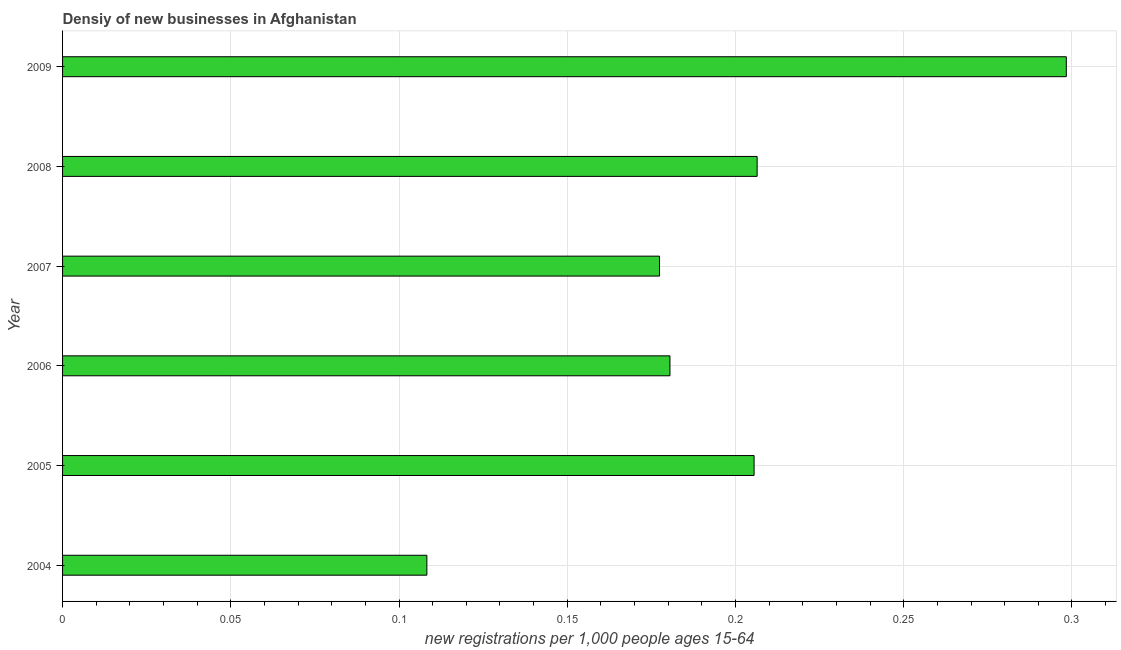What is the title of the graph?
Offer a very short reply. Densiy of new businesses in Afghanistan. What is the label or title of the X-axis?
Make the answer very short. New registrations per 1,0 people ages 15-64. What is the label or title of the Y-axis?
Ensure brevity in your answer.  Year. What is the density of new business in 2007?
Give a very brief answer. 0.18. Across all years, what is the maximum density of new business?
Your answer should be compact. 0.3. Across all years, what is the minimum density of new business?
Keep it short and to the point. 0.11. What is the sum of the density of new business?
Offer a terse response. 1.18. What is the difference between the density of new business in 2004 and 2007?
Keep it short and to the point. -0.07. What is the average density of new business per year?
Ensure brevity in your answer.  0.2. What is the median density of new business?
Your response must be concise. 0.19. What is the ratio of the density of new business in 2005 to that in 2006?
Your answer should be compact. 1.14. What is the difference between the highest and the second highest density of new business?
Offer a terse response. 0.09. Is the sum of the density of new business in 2005 and 2008 greater than the maximum density of new business across all years?
Provide a short and direct response. Yes. What is the difference between the highest and the lowest density of new business?
Provide a short and direct response. 0.19. In how many years, is the density of new business greater than the average density of new business taken over all years?
Keep it short and to the point. 3. How many bars are there?
Give a very brief answer. 6. What is the difference between two consecutive major ticks on the X-axis?
Give a very brief answer. 0.05. What is the new registrations per 1,000 people ages 15-64 of 2004?
Give a very brief answer. 0.11. What is the new registrations per 1,000 people ages 15-64 of 2005?
Provide a short and direct response. 0.21. What is the new registrations per 1,000 people ages 15-64 of 2006?
Offer a terse response. 0.18. What is the new registrations per 1,000 people ages 15-64 of 2007?
Provide a short and direct response. 0.18. What is the new registrations per 1,000 people ages 15-64 of 2008?
Ensure brevity in your answer.  0.21. What is the new registrations per 1,000 people ages 15-64 in 2009?
Your response must be concise. 0.3. What is the difference between the new registrations per 1,000 people ages 15-64 in 2004 and 2005?
Offer a very short reply. -0.1. What is the difference between the new registrations per 1,000 people ages 15-64 in 2004 and 2006?
Your answer should be very brief. -0.07. What is the difference between the new registrations per 1,000 people ages 15-64 in 2004 and 2007?
Your answer should be very brief. -0.07. What is the difference between the new registrations per 1,000 people ages 15-64 in 2004 and 2008?
Provide a short and direct response. -0.1. What is the difference between the new registrations per 1,000 people ages 15-64 in 2004 and 2009?
Your answer should be compact. -0.19. What is the difference between the new registrations per 1,000 people ages 15-64 in 2005 and 2006?
Offer a terse response. 0.03. What is the difference between the new registrations per 1,000 people ages 15-64 in 2005 and 2007?
Give a very brief answer. 0.03. What is the difference between the new registrations per 1,000 people ages 15-64 in 2005 and 2008?
Keep it short and to the point. -0. What is the difference between the new registrations per 1,000 people ages 15-64 in 2005 and 2009?
Provide a succinct answer. -0.09. What is the difference between the new registrations per 1,000 people ages 15-64 in 2006 and 2007?
Your answer should be compact. 0. What is the difference between the new registrations per 1,000 people ages 15-64 in 2006 and 2008?
Provide a succinct answer. -0.03. What is the difference between the new registrations per 1,000 people ages 15-64 in 2006 and 2009?
Your answer should be very brief. -0.12. What is the difference between the new registrations per 1,000 people ages 15-64 in 2007 and 2008?
Keep it short and to the point. -0.03. What is the difference between the new registrations per 1,000 people ages 15-64 in 2007 and 2009?
Your answer should be very brief. -0.12. What is the difference between the new registrations per 1,000 people ages 15-64 in 2008 and 2009?
Provide a succinct answer. -0.09. What is the ratio of the new registrations per 1,000 people ages 15-64 in 2004 to that in 2005?
Offer a terse response. 0.53. What is the ratio of the new registrations per 1,000 people ages 15-64 in 2004 to that in 2007?
Ensure brevity in your answer.  0.61. What is the ratio of the new registrations per 1,000 people ages 15-64 in 2004 to that in 2008?
Offer a very short reply. 0.53. What is the ratio of the new registrations per 1,000 people ages 15-64 in 2004 to that in 2009?
Ensure brevity in your answer.  0.36. What is the ratio of the new registrations per 1,000 people ages 15-64 in 2005 to that in 2006?
Offer a very short reply. 1.14. What is the ratio of the new registrations per 1,000 people ages 15-64 in 2005 to that in 2007?
Offer a very short reply. 1.16. What is the ratio of the new registrations per 1,000 people ages 15-64 in 2005 to that in 2009?
Offer a very short reply. 0.69. What is the ratio of the new registrations per 1,000 people ages 15-64 in 2006 to that in 2007?
Make the answer very short. 1.02. What is the ratio of the new registrations per 1,000 people ages 15-64 in 2006 to that in 2008?
Give a very brief answer. 0.87. What is the ratio of the new registrations per 1,000 people ages 15-64 in 2006 to that in 2009?
Make the answer very short. 0.6. What is the ratio of the new registrations per 1,000 people ages 15-64 in 2007 to that in 2008?
Your answer should be compact. 0.86. What is the ratio of the new registrations per 1,000 people ages 15-64 in 2007 to that in 2009?
Provide a succinct answer. 0.59. What is the ratio of the new registrations per 1,000 people ages 15-64 in 2008 to that in 2009?
Give a very brief answer. 0.69. 